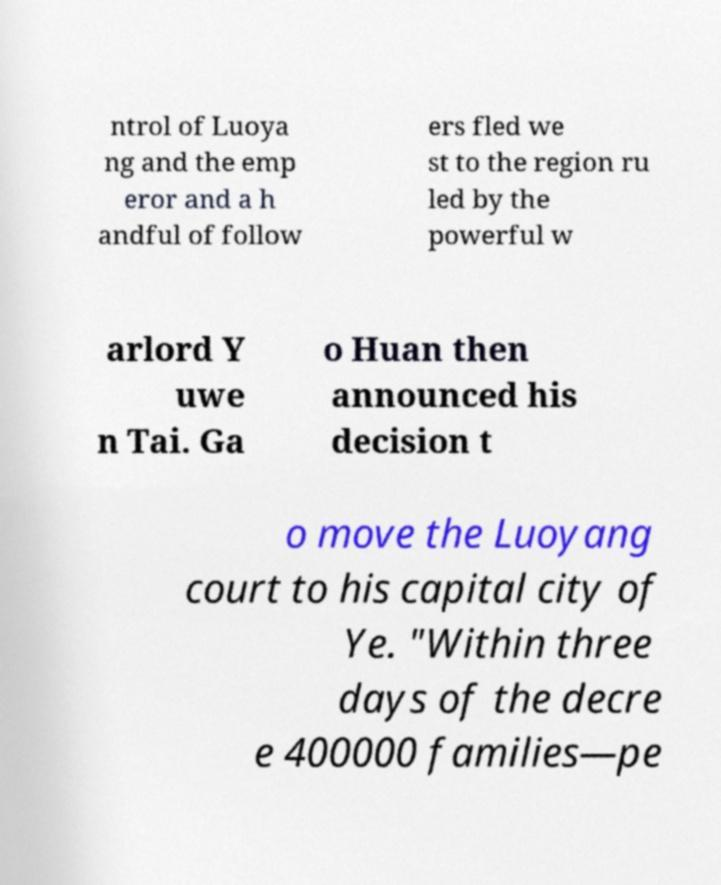For documentation purposes, I need the text within this image transcribed. Could you provide that? ntrol of Luoya ng and the emp eror and a h andful of follow ers fled we st to the region ru led by the powerful w arlord Y uwe n Tai. Ga o Huan then announced his decision t o move the Luoyang court to his capital city of Ye. "Within three days of the decre e 400000 families—pe 